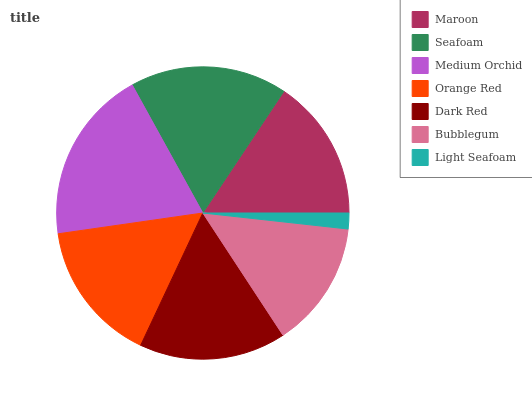Is Light Seafoam the minimum?
Answer yes or no. Yes. Is Medium Orchid the maximum?
Answer yes or no. Yes. Is Seafoam the minimum?
Answer yes or no. No. Is Seafoam the maximum?
Answer yes or no. No. Is Seafoam greater than Maroon?
Answer yes or no. Yes. Is Maroon less than Seafoam?
Answer yes or no. Yes. Is Maroon greater than Seafoam?
Answer yes or no. No. Is Seafoam less than Maroon?
Answer yes or no. No. Is Orange Red the high median?
Answer yes or no. Yes. Is Orange Red the low median?
Answer yes or no. Yes. Is Dark Red the high median?
Answer yes or no. No. Is Medium Orchid the low median?
Answer yes or no. No. 